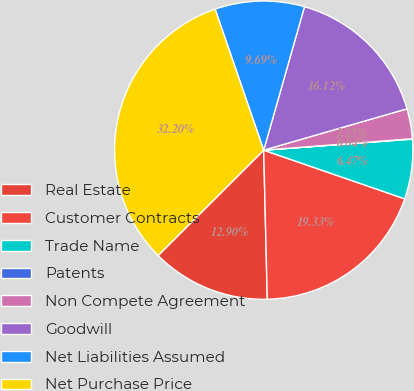Convert chart to OTSL. <chart><loc_0><loc_0><loc_500><loc_500><pie_chart><fcel>Real Estate<fcel>Customer Contracts<fcel>Trade Name<fcel>Patents<fcel>Non Compete Agreement<fcel>Goodwill<fcel>Net Liabilities Assumed<fcel>Net Purchase Price<nl><fcel>12.9%<fcel>19.33%<fcel>6.47%<fcel>0.04%<fcel>3.25%<fcel>16.12%<fcel>9.69%<fcel>32.2%<nl></chart> 